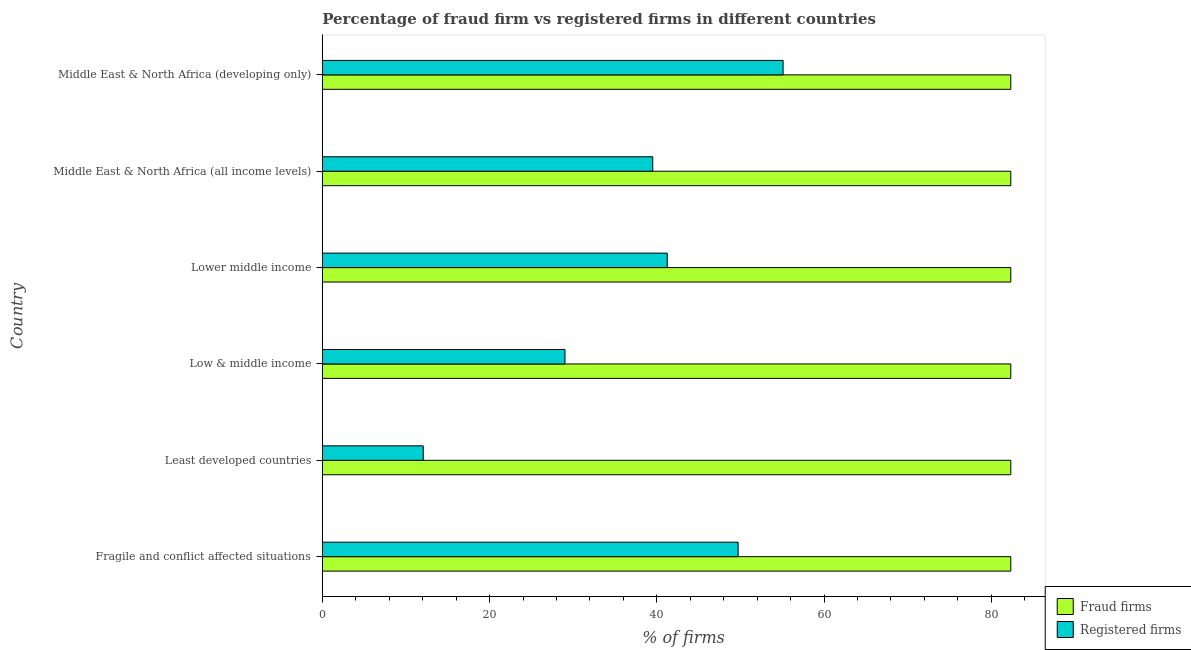How many groups of bars are there?
Your answer should be very brief. 6. Are the number of bars on each tick of the Y-axis equal?
Your answer should be compact. Yes. How many bars are there on the 6th tick from the top?
Offer a very short reply. 2. How many bars are there on the 1st tick from the bottom?
Your answer should be very brief. 2. What is the label of the 2nd group of bars from the top?
Provide a short and direct response. Middle East & North Africa (all income levels). What is the percentage of fraud firms in Fragile and conflict affected situations?
Make the answer very short. 82.33. Across all countries, what is the maximum percentage of registered firms?
Provide a short and direct response. 55.1. Across all countries, what is the minimum percentage of fraud firms?
Provide a short and direct response. 82.33. In which country was the percentage of registered firms maximum?
Ensure brevity in your answer.  Middle East & North Africa (developing only). In which country was the percentage of registered firms minimum?
Keep it short and to the point. Least developed countries. What is the total percentage of fraud firms in the graph?
Offer a very short reply. 493.98. What is the difference between the percentage of fraud firms in Least developed countries and that in Low & middle income?
Provide a short and direct response. 0. What is the difference between the percentage of fraud firms in Low & middle income and the percentage of registered firms in Least developed countries?
Give a very brief answer. 70.26. What is the average percentage of fraud firms per country?
Make the answer very short. 82.33. What is the difference between the percentage of fraud firms and percentage of registered firms in Least developed countries?
Ensure brevity in your answer.  70.26. In how many countries, is the percentage of registered firms greater than 4 %?
Your response must be concise. 6. What is the ratio of the percentage of registered firms in Least developed countries to that in Lower middle income?
Provide a short and direct response. 0.29. Is the percentage of registered firms in Fragile and conflict affected situations less than that in Lower middle income?
Provide a short and direct response. No. What is the difference between the highest and the second highest percentage of registered firms?
Make the answer very short. 5.38. What is the difference between the highest and the lowest percentage of fraud firms?
Provide a short and direct response. 0. Is the sum of the percentage of fraud firms in Lower middle income and Middle East & North Africa (developing only) greater than the maximum percentage of registered firms across all countries?
Your response must be concise. Yes. What does the 1st bar from the top in Least developed countries represents?
Offer a terse response. Registered firms. What does the 2nd bar from the bottom in Middle East & North Africa (all income levels) represents?
Your response must be concise. Registered firms. Are the values on the major ticks of X-axis written in scientific E-notation?
Offer a very short reply. No. Does the graph contain any zero values?
Your answer should be compact. No. Does the graph contain grids?
Your answer should be very brief. No. Where does the legend appear in the graph?
Make the answer very short. Bottom right. What is the title of the graph?
Ensure brevity in your answer.  Percentage of fraud firm vs registered firms in different countries. Does "Attending school" appear as one of the legend labels in the graph?
Ensure brevity in your answer.  No. What is the label or title of the X-axis?
Ensure brevity in your answer.  % of firms. What is the % of firms of Fraud firms in Fragile and conflict affected situations?
Your answer should be compact. 82.33. What is the % of firms in Registered firms in Fragile and conflict affected situations?
Offer a very short reply. 49.72. What is the % of firms of Fraud firms in Least developed countries?
Offer a very short reply. 82.33. What is the % of firms in Registered firms in Least developed countries?
Provide a succinct answer. 12.07. What is the % of firms of Fraud firms in Low & middle income?
Provide a short and direct response. 82.33. What is the % of firms in Registered firms in Low & middle income?
Ensure brevity in your answer.  29.02. What is the % of firms in Fraud firms in Lower middle income?
Make the answer very short. 82.33. What is the % of firms in Registered firms in Lower middle income?
Offer a very short reply. 41.24. What is the % of firms of Fraud firms in Middle East & North Africa (all income levels)?
Your answer should be compact. 82.33. What is the % of firms of Registered firms in Middle East & North Africa (all income levels)?
Provide a succinct answer. 39.51. What is the % of firms in Fraud firms in Middle East & North Africa (developing only)?
Keep it short and to the point. 82.33. What is the % of firms of Registered firms in Middle East & North Africa (developing only)?
Ensure brevity in your answer.  55.1. Across all countries, what is the maximum % of firms of Fraud firms?
Offer a terse response. 82.33. Across all countries, what is the maximum % of firms in Registered firms?
Ensure brevity in your answer.  55.1. Across all countries, what is the minimum % of firms in Fraud firms?
Offer a very short reply. 82.33. Across all countries, what is the minimum % of firms in Registered firms?
Make the answer very short. 12.07. What is the total % of firms of Fraud firms in the graph?
Provide a succinct answer. 493.98. What is the total % of firms in Registered firms in the graph?
Offer a terse response. 226.66. What is the difference between the % of firms of Fraud firms in Fragile and conflict affected situations and that in Least developed countries?
Provide a succinct answer. 0. What is the difference between the % of firms of Registered firms in Fragile and conflict affected situations and that in Least developed countries?
Give a very brief answer. 37.66. What is the difference between the % of firms of Registered firms in Fragile and conflict affected situations and that in Low & middle income?
Provide a short and direct response. 20.71. What is the difference between the % of firms in Registered firms in Fragile and conflict affected situations and that in Lower middle income?
Provide a short and direct response. 8.48. What is the difference between the % of firms of Fraud firms in Fragile and conflict affected situations and that in Middle East & North Africa (all income levels)?
Keep it short and to the point. 0. What is the difference between the % of firms of Registered firms in Fragile and conflict affected situations and that in Middle East & North Africa (all income levels)?
Make the answer very short. 10.21. What is the difference between the % of firms in Fraud firms in Fragile and conflict affected situations and that in Middle East & North Africa (developing only)?
Your response must be concise. 0. What is the difference between the % of firms in Registered firms in Fragile and conflict affected situations and that in Middle East & North Africa (developing only)?
Offer a terse response. -5.38. What is the difference between the % of firms in Registered firms in Least developed countries and that in Low & middle income?
Make the answer very short. -16.95. What is the difference between the % of firms of Fraud firms in Least developed countries and that in Lower middle income?
Offer a very short reply. 0. What is the difference between the % of firms in Registered firms in Least developed countries and that in Lower middle income?
Give a very brief answer. -29.18. What is the difference between the % of firms of Fraud firms in Least developed countries and that in Middle East & North Africa (all income levels)?
Your response must be concise. 0. What is the difference between the % of firms in Registered firms in Least developed countries and that in Middle East & North Africa (all income levels)?
Ensure brevity in your answer.  -27.45. What is the difference between the % of firms in Registered firms in Least developed countries and that in Middle East & North Africa (developing only)?
Ensure brevity in your answer.  -43.03. What is the difference between the % of firms in Fraud firms in Low & middle income and that in Lower middle income?
Provide a short and direct response. 0. What is the difference between the % of firms in Registered firms in Low & middle income and that in Lower middle income?
Provide a short and direct response. -12.23. What is the difference between the % of firms in Registered firms in Low & middle income and that in Middle East & North Africa (all income levels)?
Make the answer very short. -10.5. What is the difference between the % of firms in Registered firms in Low & middle income and that in Middle East & North Africa (developing only)?
Your response must be concise. -26.08. What is the difference between the % of firms in Fraud firms in Lower middle income and that in Middle East & North Africa (all income levels)?
Give a very brief answer. 0. What is the difference between the % of firms of Registered firms in Lower middle income and that in Middle East & North Africa (all income levels)?
Provide a short and direct response. 1.73. What is the difference between the % of firms of Registered firms in Lower middle income and that in Middle East & North Africa (developing only)?
Give a very brief answer. -13.86. What is the difference between the % of firms in Fraud firms in Middle East & North Africa (all income levels) and that in Middle East & North Africa (developing only)?
Your answer should be very brief. 0. What is the difference between the % of firms in Registered firms in Middle East & North Africa (all income levels) and that in Middle East & North Africa (developing only)?
Ensure brevity in your answer.  -15.59. What is the difference between the % of firms in Fraud firms in Fragile and conflict affected situations and the % of firms in Registered firms in Least developed countries?
Offer a terse response. 70.26. What is the difference between the % of firms in Fraud firms in Fragile and conflict affected situations and the % of firms in Registered firms in Low & middle income?
Give a very brief answer. 53.31. What is the difference between the % of firms in Fraud firms in Fragile and conflict affected situations and the % of firms in Registered firms in Lower middle income?
Ensure brevity in your answer.  41.09. What is the difference between the % of firms in Fraud firms in Fragile and conflict affected situations and the % of firms in Registered firms in Middle East & North Africa (all income levels)?
Your response must be concise. 42.82. What is the difference between the % of firms in Fraud firms in Fragile and conflict affected situations and the % of firms in Registered firms in Middle East & North Africa (developing only)?
Make the answer very short. 27.23. What is the difference between the % of firms of Fraud firms in Least developed countries and the % of firms of Registered firms in Low & middle income?
Make the answer very short. 53.31. What is the difference between the % of firms in Fraud firms in Least developed countries and the % of firms in Registered firms in Lower middle income?
Your response must be concise. 41.09. What is the difference between the % of firms in Fraud firms in Least developed countries and the % of firms in Registered firms in Middle East & North Africa (all income levels)?
Your response must be concise. 42.82. What is the difference between the % of firms in Fraud firms in Least developed countries and the % of firms in Registered firms in Middle East & North Africa (developing only)?
Keep it short and to the point. 27.23. What is the difference between the % of firms in Fraud firms in Low & middle income and the % of firms in Registered firms in Lower middle income?
Provide a succinct answer. 41.09. What is the difference between the % of firms of Fraud firms in Low & middle income and the % of firms of Registered firms in Middle East & North Africa (all income levels)?
Give a very brief answer. 42.82. What is the difference between the % of firms in Fraud firms in Low & middle income and the % of firms in Registered firms in Middle East & North Africa (developing only)?
Ensure brevity in your answer.  27.23. What is the difference between the % of firms in Fraud firms in Lower middle income and the % of firms in Registered firms in Middle East & North Africa (all income levels)?
Offer a terse response. 42.82. What is the difference between the % of firms in Fraud firms in Lower middle income and the % of firms in Registered firms in Middle East & North Africa (developing only)?
Your answer should be very brief. 27.23. What is the difference between the % of firms in Fraud firms in Middle East & North Africa (all income levels) and the % of firms in Registered firms in Middle East & North Africa (developing only)?
Keep it short and to the point. 27.23. What is the average % of firms in Fraud firms per country?
Offer a terse response. 82.33. What is the average % of firms in Registered firms per country?
Your answer should be compact. 37.78. What is the difference between the % of firms in Fraud firms and % of firms in Registered firms in Fragile and conflict affected situations?
Ensure brevity in your answer.  32.61. What is the difference between the % of firms in Fraud firms and % of firms in Registered firms in Least developed countries?
Make the answer very short. 70.26. What is the difference between the % of firms in Fraud firms and % of firms in Registered firms in Low & middle income?
Offer a very short reply. 53.31. What is the difference between the % of firms of Fraud firms and % of firms of Registered firms in Lower middle income?
Provide a short and direct response. 41.09. What is the difference between the % of firms of Fraud firms and % of firms of Registered firms in Middle East & North Africa (all income levels)?
Give a very brief answer. 42.82. What is the difference between the % of firms of Fraud firms and % of firms of Registered firms in Middle East & North Africa (developing only)?
Your answer should be very brief. 27.23. What is the ratio of the % of firms of Fraud firms in Fragile and conflict affected situations to that in Least developed countries?
Your response must be concise. 1. What is the ratio of the % of firms of Registered firms in Fragile and conflict affected situations to that in Least developed countries?
Your response must be concise. 4.12. What is the ratio of the % of firms of Fraud firms in Fragile and conflict affected situations to that in Low & middle income?
Provide a succinct answer. 1. What is the ratio of the % of firms of Registered firms in Fragile and conflict affected situations to that in Low & middle income?
Provide a short and direct response. 1.71. What is the ratio of the % of firms of Registered firms in Fragile and conflict affected situations to that in Lower middle income?
Give a very brief answer. 1.21. What is the ratio of the % of firms in Fraud firms in Fragile and conflict affected situations to that in Middle East & North Africa (all income levels)?
Make the answer very short. 1. What is the ratio of the % of firms in Registered firms in Fragile and conflict affected situations to that in Middle East & North Africa (all income levels)?
Give a very brief answer. 1.26. What is the ratio of the % of firms of Fraud firms in Fragile and conflict affected situations to that in Middle East & North Africa (developing only)?
Make the answer very short. 1. What is the ratio of the % of firms in Registered firms in Fragile and conflict affected situations to that in Middle East & North Africa (developing only)?
Keep it short and to the point. 0.9. What is the ratio of the % of firms of Fraud firms in Least developed countries to that in Low & middle income?
Your answer should be very brief. 1. What is the ratio of the % of firms in Registered firms in Least developed countries to that in Low & middle income?
Offer a very short reply. 0.42. What is the ratio of the % of firms in Fraud firms in Least developed countries to that in Lower middle income?
Make the answer very short. 1. What is the ratio of the % of firms of Registered firms in Least developed countries to that in Lower middle income?
Give a very brief answer. 0.29. What is the ratio of the % of firms of Registered firms in Least developed countries to that in Middle East & North Africa (all income levels)?
Give a very brief answer. 0.31. What is the ratio of the % of firms in Registered firms in Least developed countries to that in Middle East & North Africa (developing only)?
Give a very brief answer. 0.22. What is the ratio of the % of firms of Registered firms in Low & middle income to that in Lower middle income?
Offer a very short reply. 0.7. What is the ratio of the % of firms in Fraud firms in Low & middle income to that in Middle East & North Africa (all income levels)?
Provide a succinct answer. 1. What is the ratio of the % of firms in Registered firms in Low & middle income to that in Middle East & North Africa (all income levels)?
Give a very brief answer. 0.73. What is the ratio of the % of firms of Fraud firms in Low & middle income to that in Middle East & North Africa (developing only)?
Provide a succinct answer. 1. What is the ratio of the % of firms of Registered firms in Low & middle income to that in Middle East & North Africa (developing only)?
Offer a very short reply. 0.53. What is the ratio of the % of firms of Registered firms in Lower middle income to that in Middle East & North Africa (all income levels)?
Your answer should be compact. 1.04. What is the ratio of the % of firms in Fraud firms in Lower middle income to that in Middle East & North Africa (developing only)?
Provide a short and direct response. 1. What is the ratio of the % of firms of Registered firms in Lower middle income to that in Middle East & North Africa (developing only)?
Keep it short and to the point. 0.75. What is the ratio of the % of firms in Registered firms in Middle East & North Africa (all income levels) to that in Middle East & North Africa (developing only)?
Offer a very short reply. 0.72. What is the difference between the highest and the second highest % of firms of Registered firms?
Provide a succinct answer. 5.38. What is the difference between the highest and the lowest % of firms in Fraud firms?
Provide a succinct answer. 0. What is the difference between the highest and the lowest % of firms of Registered firms?
Your answer should be very brief. 43.03. 